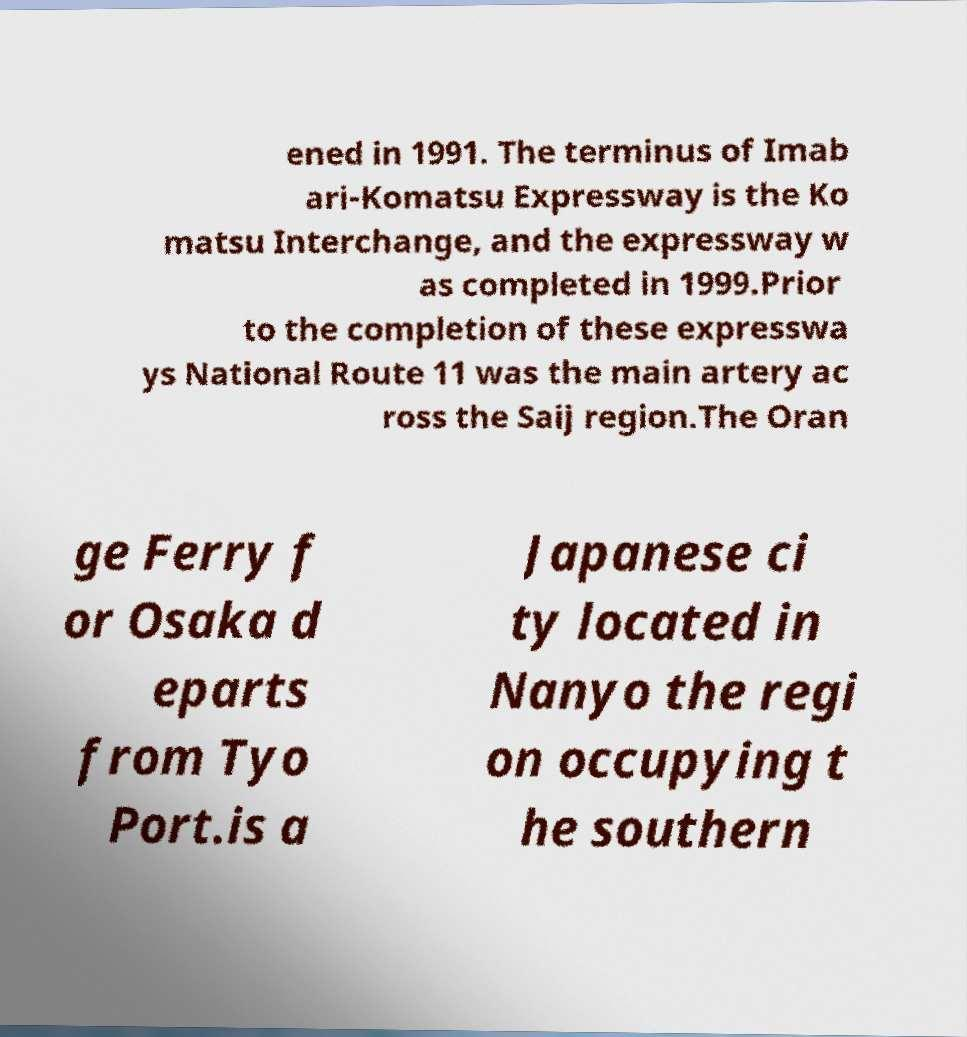Please identify and transcribe the text found in this image. ened in 1991. The terminus of Imab ari-Komatsu Expressway is the Ko matsu Interchange, and the expressway w as completed in 1999.Prior to the completion of these expresswa ys National Route 11 was the main artery ac ross the Saij region.The Oran ge Ferry f or Osaka d eparts from Tyo Port.is a Japanese ci ty located in Nanyo the regi on occupying t he southern 